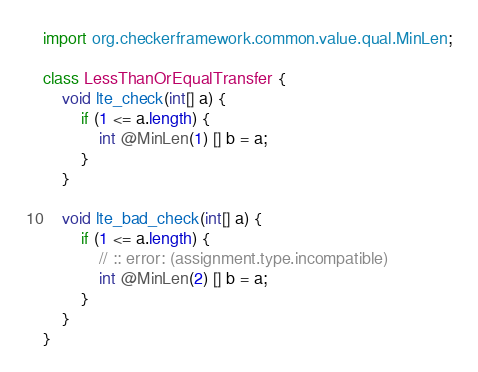Convert code to text. <code><loc_0><loc_0><loc_500><loc_500><_Java_>import org.checkerframework.common.value.qual.MinLen;

class LessThanOrEqualTransfer {
    void lte_check(int[] a) {
        if (1 <= a.length) {
            int @MinLen(1) [] b = a;
        }
    }

    void lte_bad_check(int[] a) {
        if (1 <= a.length) {
            // :: error: (assignment.type.incompatible)
            int @MinLen(2) [] b = a;
        }
    }
}
</code> 